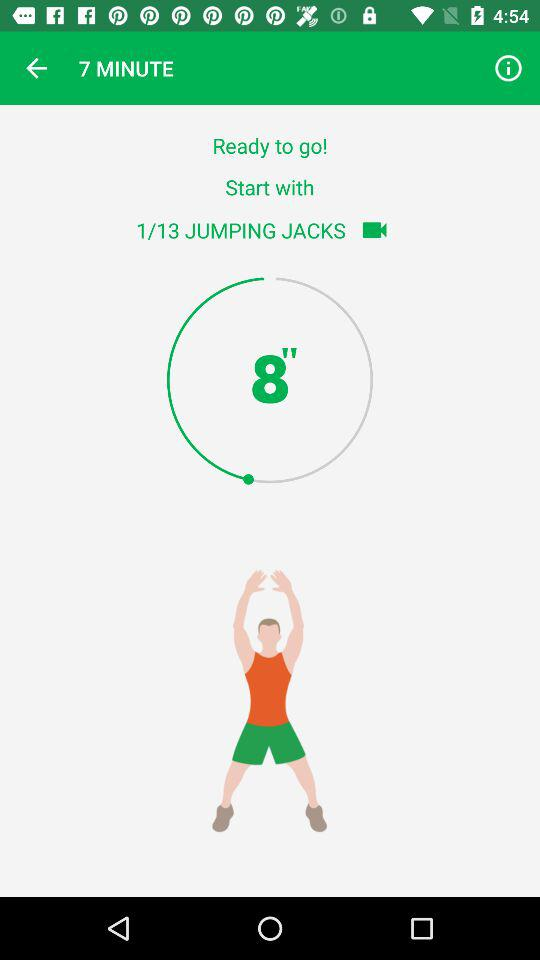How many more jumping jacks do I have to do?
Answer the question using a single word or phrase. 12 